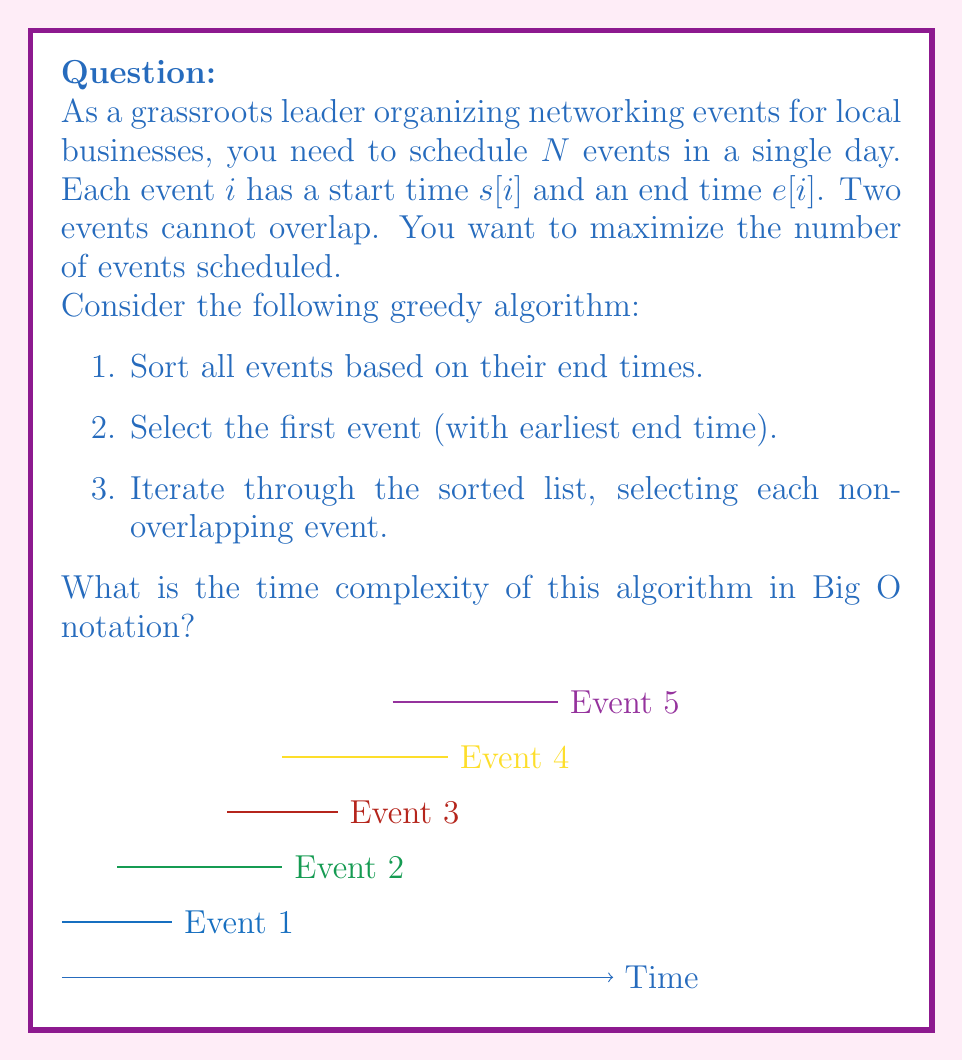Can you answer this question? Let's analyze the time complexity of this algorithm step by step:

1. Sorting the events:
   The first step is to sort all N events based on their end times. Using an efficient sorting algorithm like Merge Sort or Heap Sort, this operation has a time complexity of $O(N \log N)$.

2. Selecting the first event:
   This is a constant time operation, $O(1)$.

3. Iterating through the sorted list:
   We iterate through the sorted list once, which takes $O(N)$ time.
   For each event, we check if it's non-overlapping with the last selected event, which is a constant time operation.

Now, let's combine these steps:

$$ T(N) = O(N \log N) + O(1) + O(N) $$

The dominant term in this expression is $O(N \log N)$ from the sorting step. The $O(N)$ term from the iteration is asymptotically smaller, and the $O(1)$ term is negligible for large N.

Therefore, the overall time complexity of the algorithm is $O(N \log N)$.

It's worth noting that this algorithm, known as the "Activity Selection Problem", achieves the optimal solution in $O(N \log N)$ time, which is efficient for scheduling a large number of events.
Answer: $O(N \log N)$ 